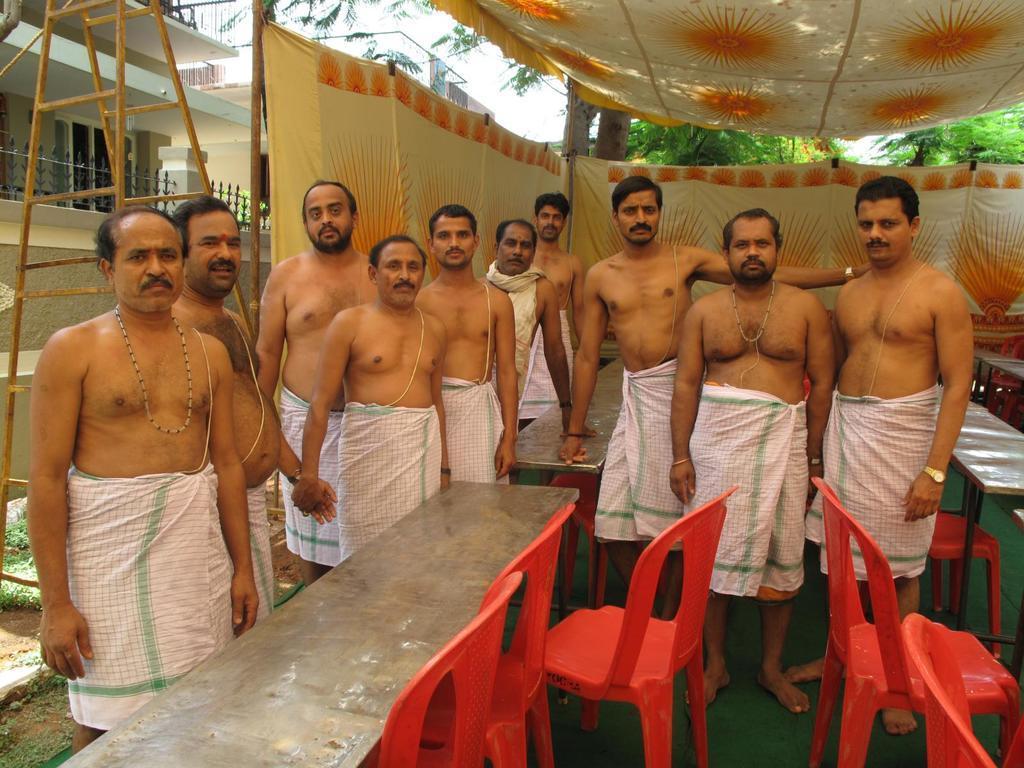Could you give a brief overview of what you see in this image? In this image, In the middle there are some chairs which are in red color and there are some tables, There are some people standing, In the background of the image, There is a yellow color cloth , In the top of the there is a yellow color shade, in the left side of the image there is a table which is in yellow color. 